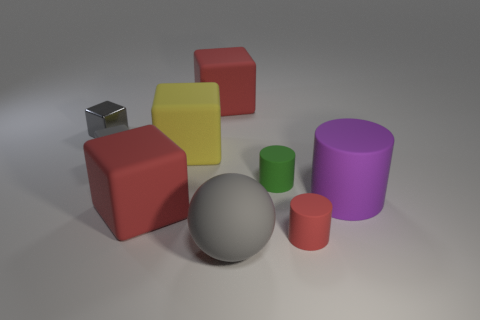What size is the red object that is behind the green object?
Your answer should be very brief. Large. Is the color of the small matte cube the same as the big thing that is to the right of the big gray rubber sphere?
Make the answer very short. No. How many other objects are there of the same material as the tiny green cylinder?
Offer a very short reply. 7. Are there more large purple matte cylinders than red metal cubes?
Ensure brevity in your answer.  Yes. Is the color of the tiny cube that is in front of the tiny gray metal thing the same as the large rubber sphere?
Provide a short and direct response. Yes. The large rubber ball is what color?
Your answer should be very brief. Gray. Is there a tiny red matte cylinder that is behind the large red object that is in front of the large purple cylinder?
Your answer should be very brief. No. There is a large matte thing on the right side of the small cylinder behind the tiny red rubber cylinder; what is its shape?
Provide a short and direct response. Cylinder. Is the number of green rubber objects less than the number of small red metallic objects?
Offer a very short reply. No. Do the yellow block and the large purple object have the same material?
Provide a succinct answer. Yes. 